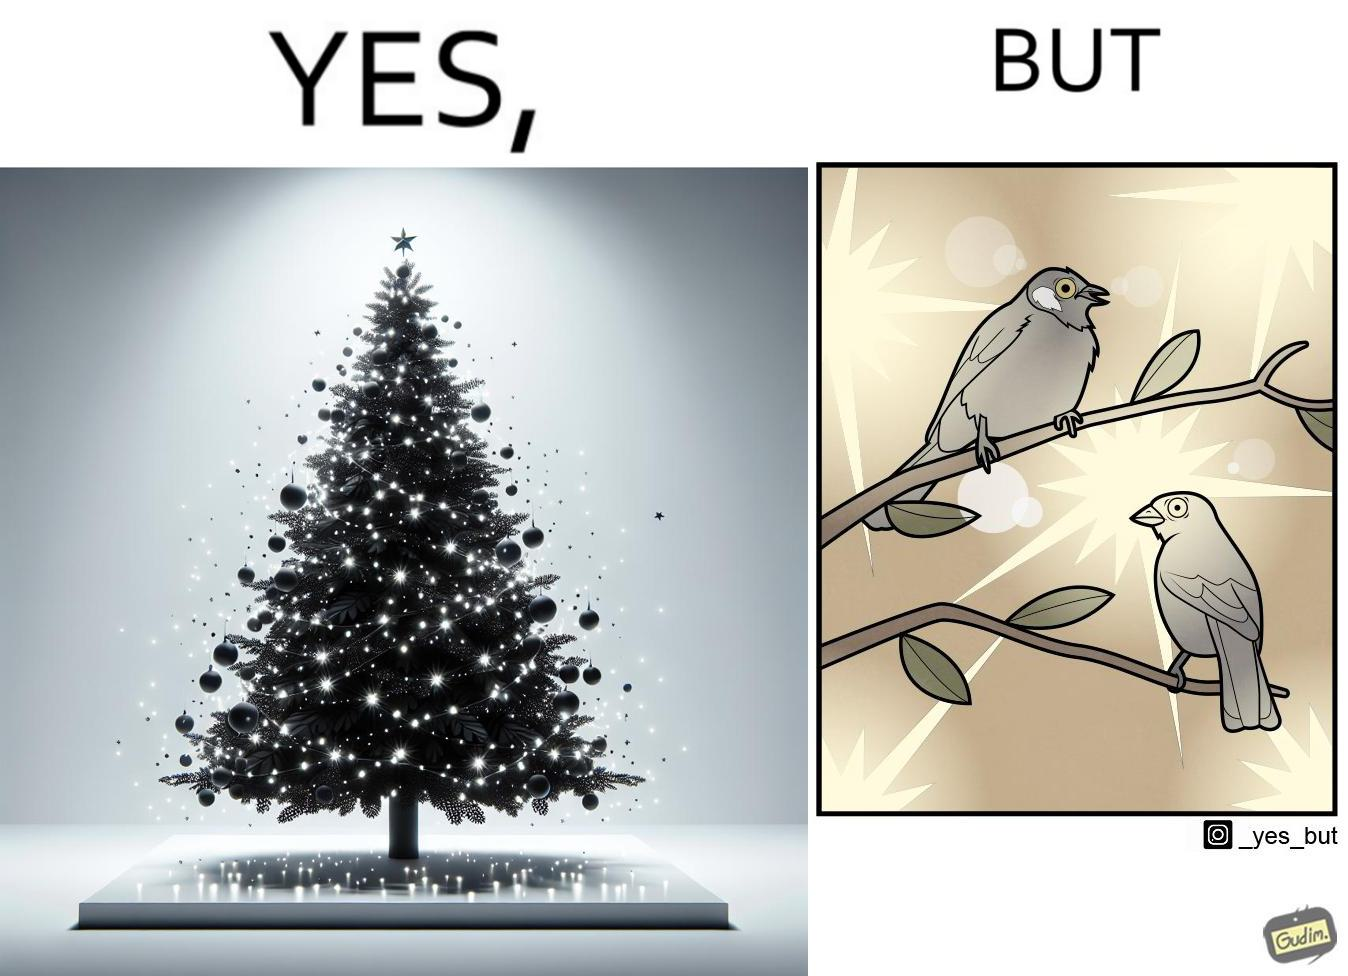Is there satirical content in this image? Yes, this image is satirical. 